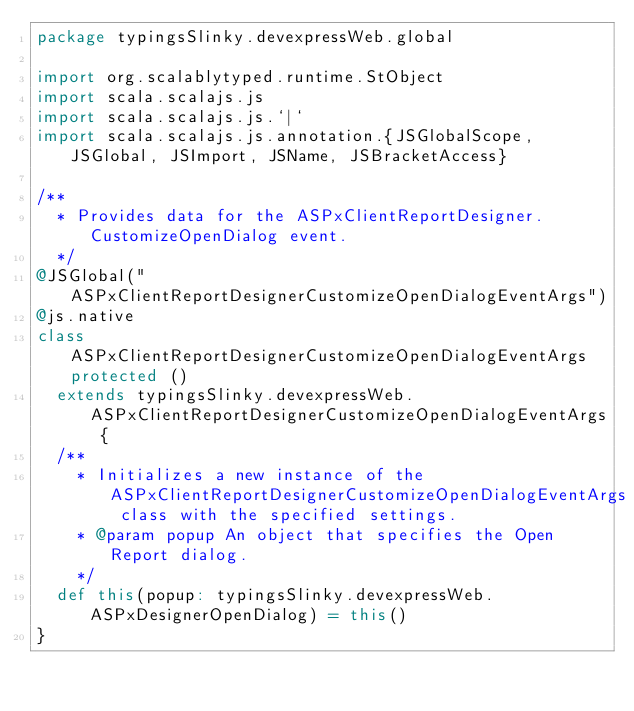Convert code to text. <code><loc_0><loc_0><loc_500><loc_500><_Scala_>package typingsSlinky.devexpressWeb.global

import org.scalablytyped.runtime.StObject
import scala.scalajs.js
import scala.scalajs.js.`|`
import scala.scalajs.js.annotation.{JSGlobalScope, JSGlobal, JSImport, JSName, JSBracketAccess}

/**
  * Provides data for the ASPxClientReportDesigner.CustomizeOpenDialog event.
  */
@JSGlobal("ASPxClientReportDesignerCustomizeOpenDialogEventArgs")
@js.native
class ASPxClientReportDesignerCustomizeOpenDialogEventArgs protected ()
  extends typingsSlinky.devexpressWeb.ASPxClientReportDesignerCustomizeOpenDialogEventArgs {
  /**
    * Initializes a new instance of the ASPxClientReportDesignerCustomizeOpenDialogEventArgs class with the specified settings.
    * @param popup An object that specifies the Open Report dialog.
    */
  def this(popup: typingsSlinky.devexpressWeb.ASPxDesignerOpenDialog) = this()
}
</code> 